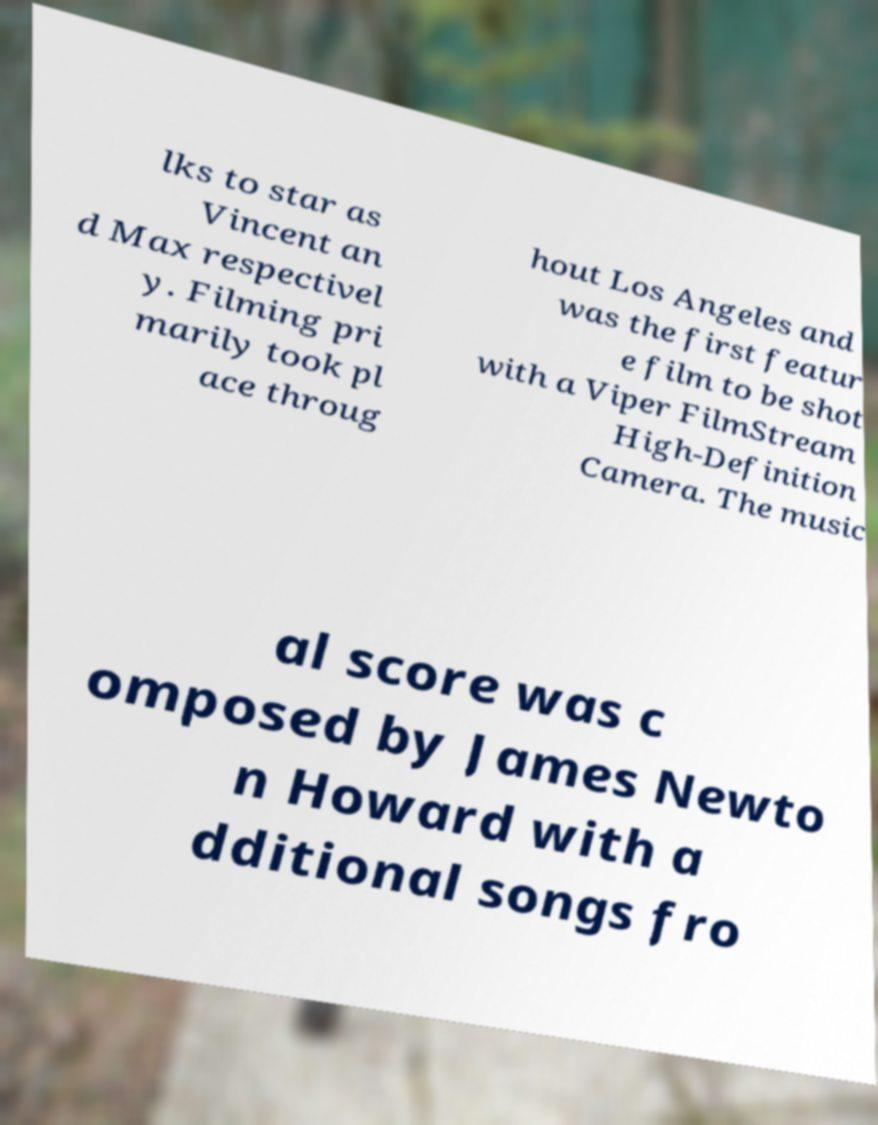Could you extract and type out the text from this image? lks to star as Vincent an d Max respectivel y. Filming pri marily took pl ace throug hout Los Angeles and was the first featur e film to be shot with a Viper FilmStream High-Definition Camera. The music al score was c omposed by James Newto n Howard with a dditional songs fro 